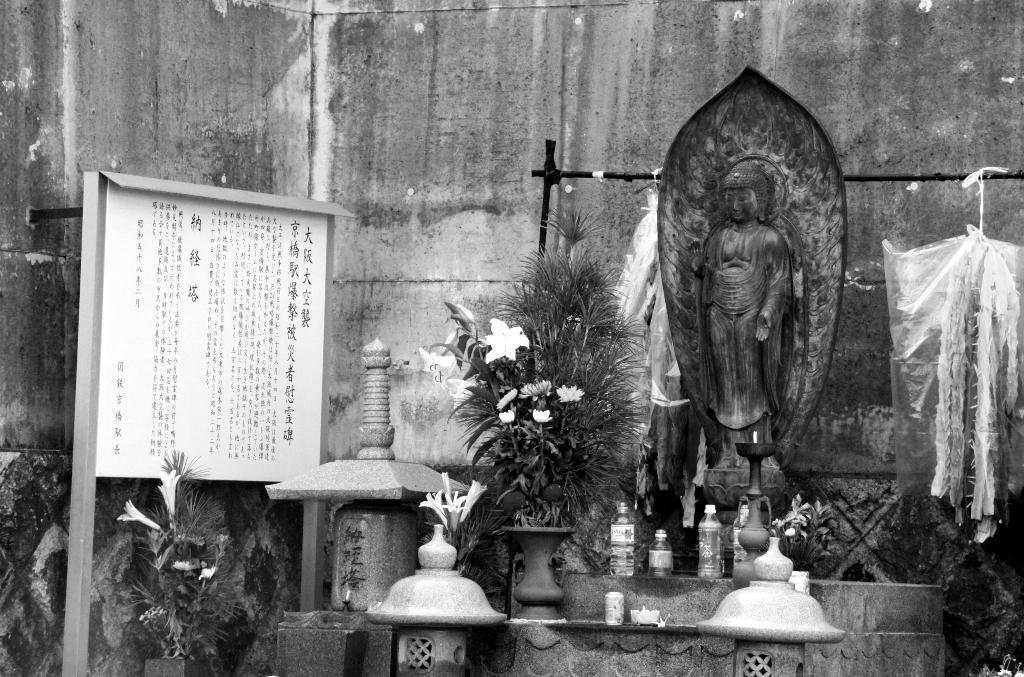What is the main object in the image? There is a statue in the image. What other items can be seen around the statue? There are bottles, a plant with flowers, polythene covers hanging, and a board with text in the image. Can you see your aunt holding a hook near the statue in the image? There is no person, including an aunt, present in the image, nor is there a hook visible. 